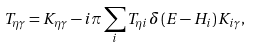Convert formula to latex. <formula><loc_0><loc_0><loc_500><loc_500>T _ { \eta \gamma } = K _ { \eta \gamma } - i \pi \sum _ { i } T _ { \eta i } \delta \left ( E - H _ { i } \right ) K _ { i \gamma } ,</formula> 